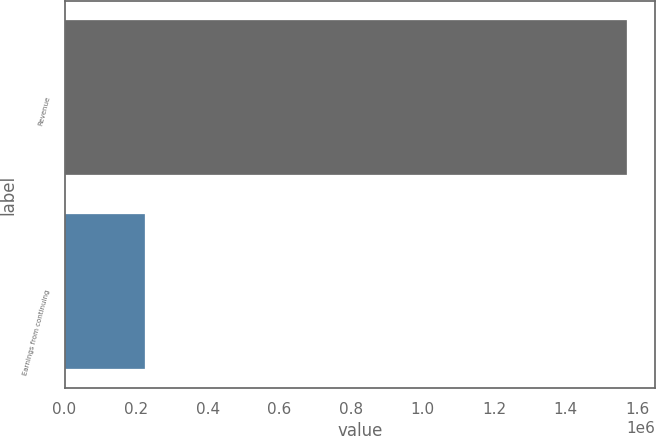<chart> <loc_0><loc_0><loc_500><loc_500><bar_chart><fcel>Revenue<fcel>Earnings from continuing<nl><fcel>1.5714e+06<fcel>224532<nl></chart> 